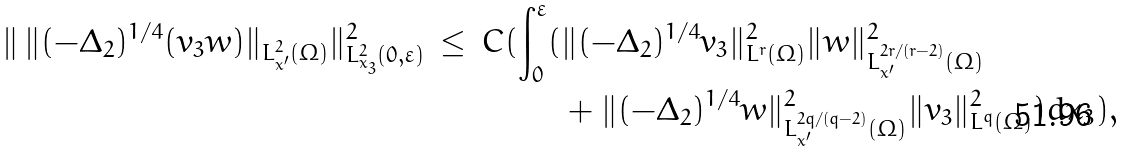Convert formula to latex. <formula><loc_0><loc_0><loc_500><loc_500>\| \, \| ( - \Delta _ { 2 } ) ^ { 1 / 4 } ( v _ { 3 } w ) \| _ { L ^ { 2 } _ { x ^ { \prime } } ( \Omega ) } \| ^ { 2 } _ { L ^ { 2 } _ { x _ { 3 } } ( 0 , \varepsilon ) } \, \leq \, C ( \int _ { 0 } ^ { \varepsilon } ( & \| ( - \Delta _ { 2 } ) ^ { 1 / 4 } v _ { 3 } \| ^ { 2 } _ { L ^ { r } ( \Omega ) } \| w \| ^ { 2 } _ { L ^ { 2 r / ( r - 2 ) } _ { x ^ { \prime } } ( \Omega ) } \\ & + \| ( - \Delta _ { 2 } ) ^ { 1 / 4 } w \| ^ { 2 } _ { L ^ { 2 q / ( q - 2 ) } _ { x ^ { \prime } } ( \Omega ) } \| v _ { 3 } \| ^ { 2 } _ { L ^ { q } ( \Omega ) } ) d x _ { 3 } ) ,</formula> 